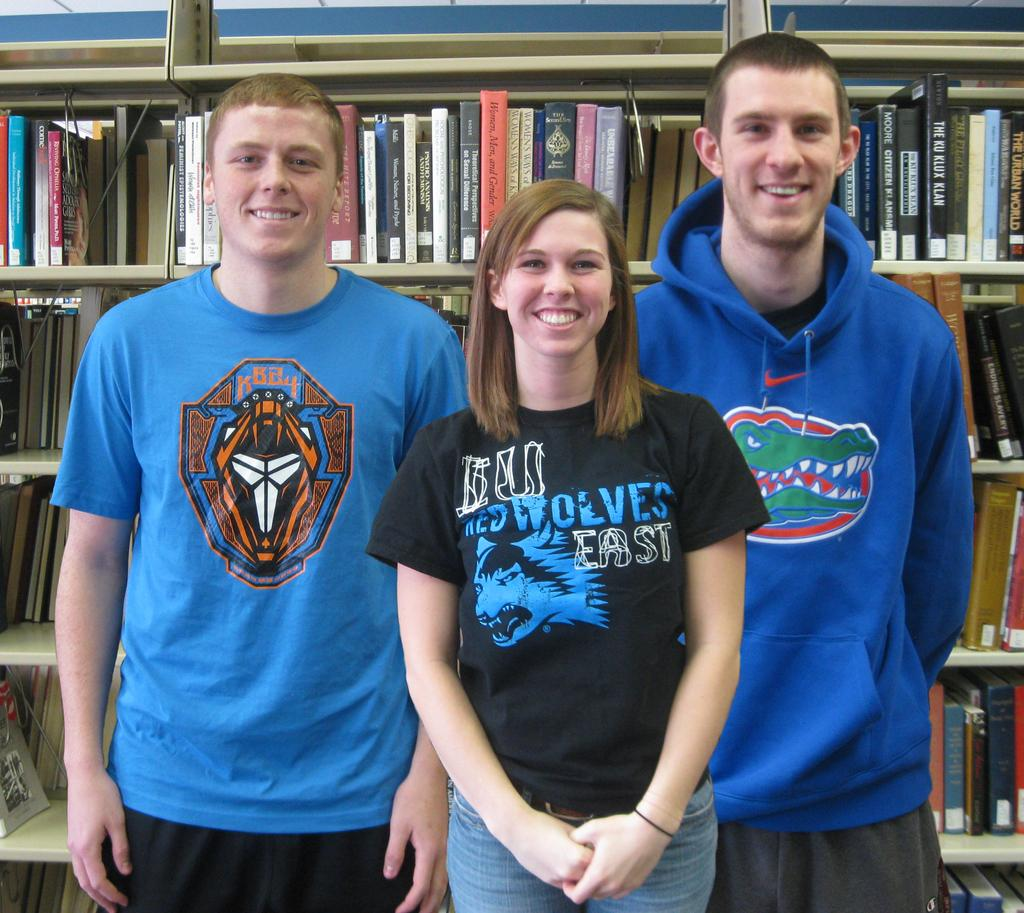Who is present in the image? There is a girl and two men in the image. What are the girl and men doing in the image? The girl and men are standing and looking at something. What can be seen in the background of the image? There are many books and bookshelves in the image. What type of food is being prepared by the girl in the image? There is no food preparation or any food visible in the image. How many dolls are present on the bookshelves in the image? There are no dolls present in the image; it features a girl and two men looking at something, along with books and bookshelves. 